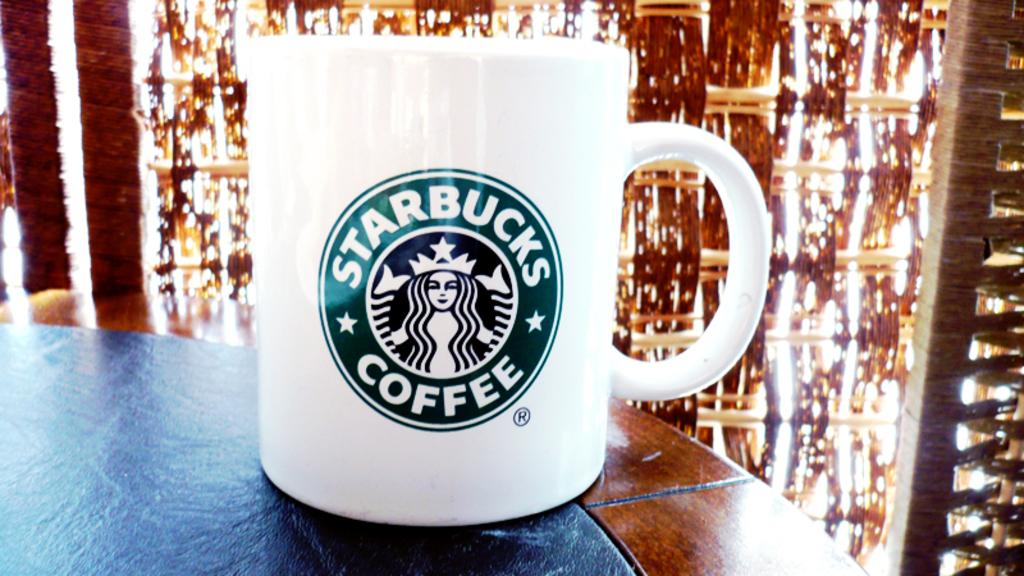What is located in the center of the image? There is a cup in the center of the image. Where is the cup placed? The cup is placed on a table. What can be seen in the background of the image? There are blinds in the background of the image. What type of wound can be seen on the cup in the image? There is no wound present on the cup in the image. What color is the crayon used to draw on the cup in the image? There is no crayon or drawing present on the cup in the image. 